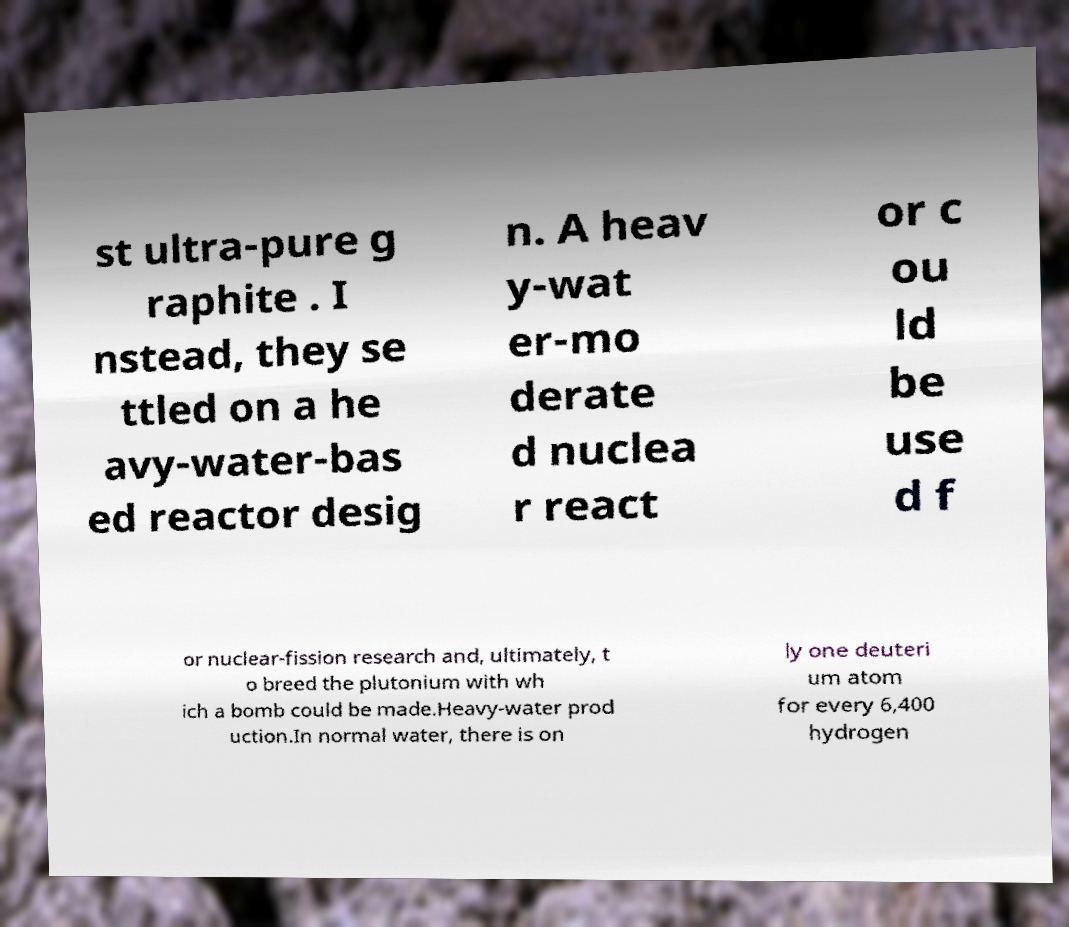Please read and relay the text visible in this image. What does it say? st ultra-pure g raphite . I nstead, they se ttled on a he avy-water-bas ed reactor desig n. A heav y-wat er-mo derate d nuclea r react or c ou ld be use d f or nuclear-fission research and, ultimately, t o breed the plutonium with wh ich a bomb could be made.Heavy-water prod uction.In normal water, there is on ly one deuteri um atom for every 6,400 hydrogen 